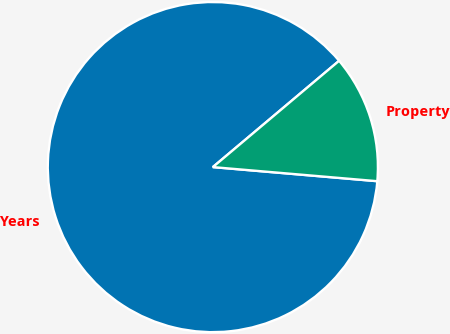Convert chart to OTSL. <chart><loc_0><loc_0><loc_500><loc_500><pie_chart><fcel>Years<fcel>Property<nl><fcel>87.5%<fcel>12.5%<nl></chart> 